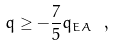<formula> <loc_0><loc_0><loc_500><loc_500>q \geq - \frac { 7 } { 5 } q _ { E A } \ ,</formula> 